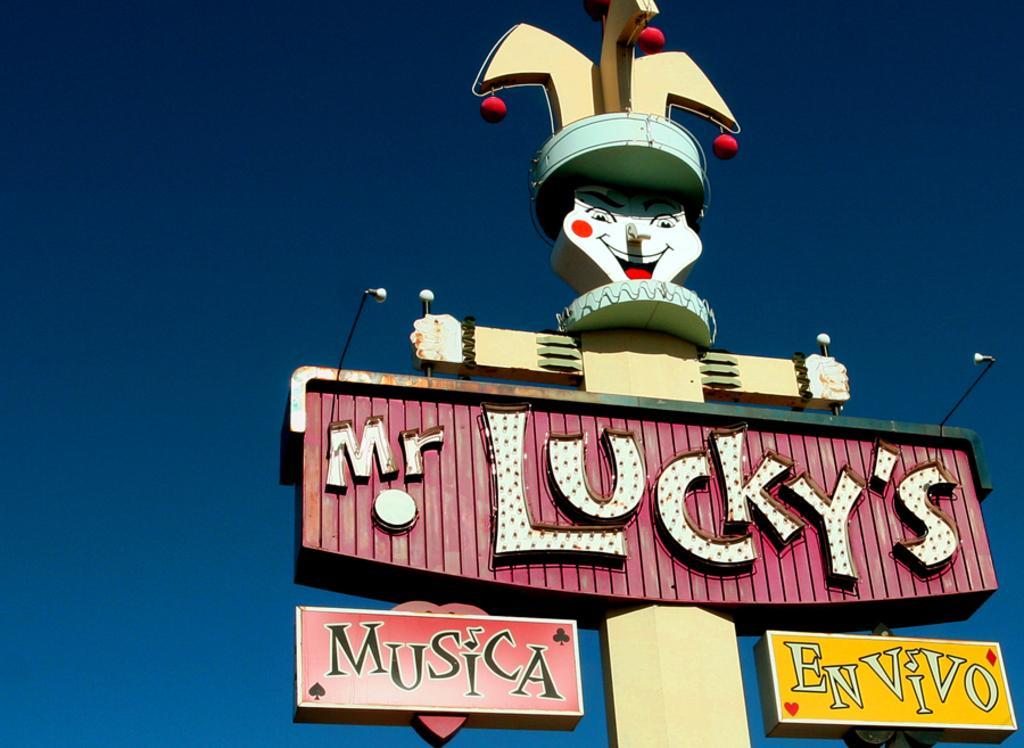How would you summarize this image in a sentence or two? In the picture we can see a pole with a board with a name on it Mr. Lucky and besides, we can see a name musical envivo and on the top of it, we can see a joker sculpture and in the background we can see a sky which is blue in color. 